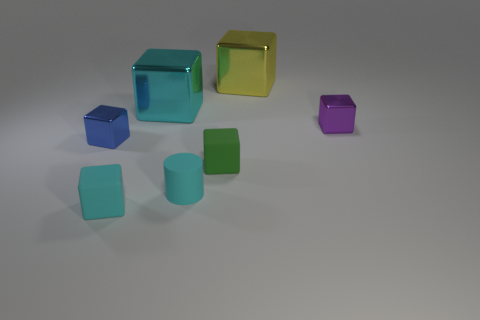There is a rubber thing that is the same color as the cylinder; what is its shape?
Give a very brief answer. Cube. What number of small things are purple rubber objects or purple blocks?
Provide a succinct answer. 1. What is the size of the matte block that is the same color as the tiny cylinder?
Make the answer very short. Small. What is the color of the small metal cube to the left of the small metallic thing that is right of the tiny green cube?
Offer a very short reply. Blue. Is the material of the purple block the same as the big cube in front of the big yellow block?
Your answer should be very brief. Yes. There is a small green block right of the large cyan object; what material is it?
Your answer should be compact. Rubber. Is the number of tiny cyan matte things right of the blue metallic object the same as the number of purple metallic cylinders?
Keep it short and to the point. No. Is there any other thing that is the same size as the blue metallic cube?
Keep it short and to the point. Yes. What is the material of the tiny cyan cylinder in front of the big metallic thing that is on the left side of the yellow object?
Provide a succinct answer. Rubber. There is a object that is both behind the small green matte thing and to the left of the cyan metallic block; what is its shape?
Ensure brevity in your answer.  Cube. 